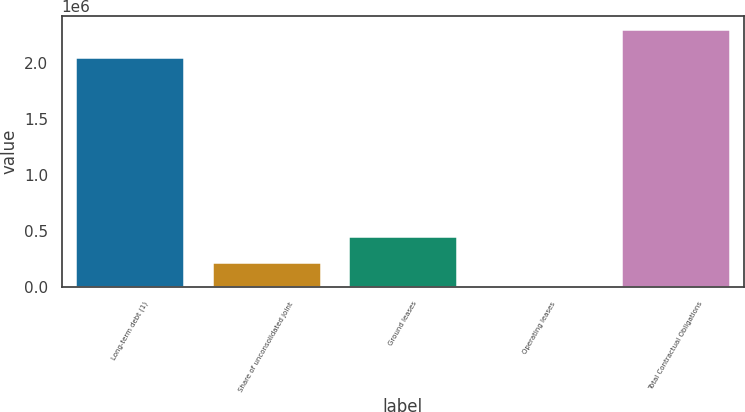Convert chart. <chart><loc_0><loc_0><loc_500><loc_500><bar_chart><fcel>Long-term debt (1)<fcel>Share of unconsolidated joint<fcel>Ground leases<fcel>Operating leases<fcel>Total Contractual Obligations<nl><fcel>2.05372e+06<fcel>231000<fcel>461408<fcel>592<fcel>2.30467e+06<nl></chart> 